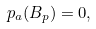<formula> <loc_0><loc_0><loc_500><loc_500>p _ { a } ( B _ { p } ) = 0 ,</formula> 